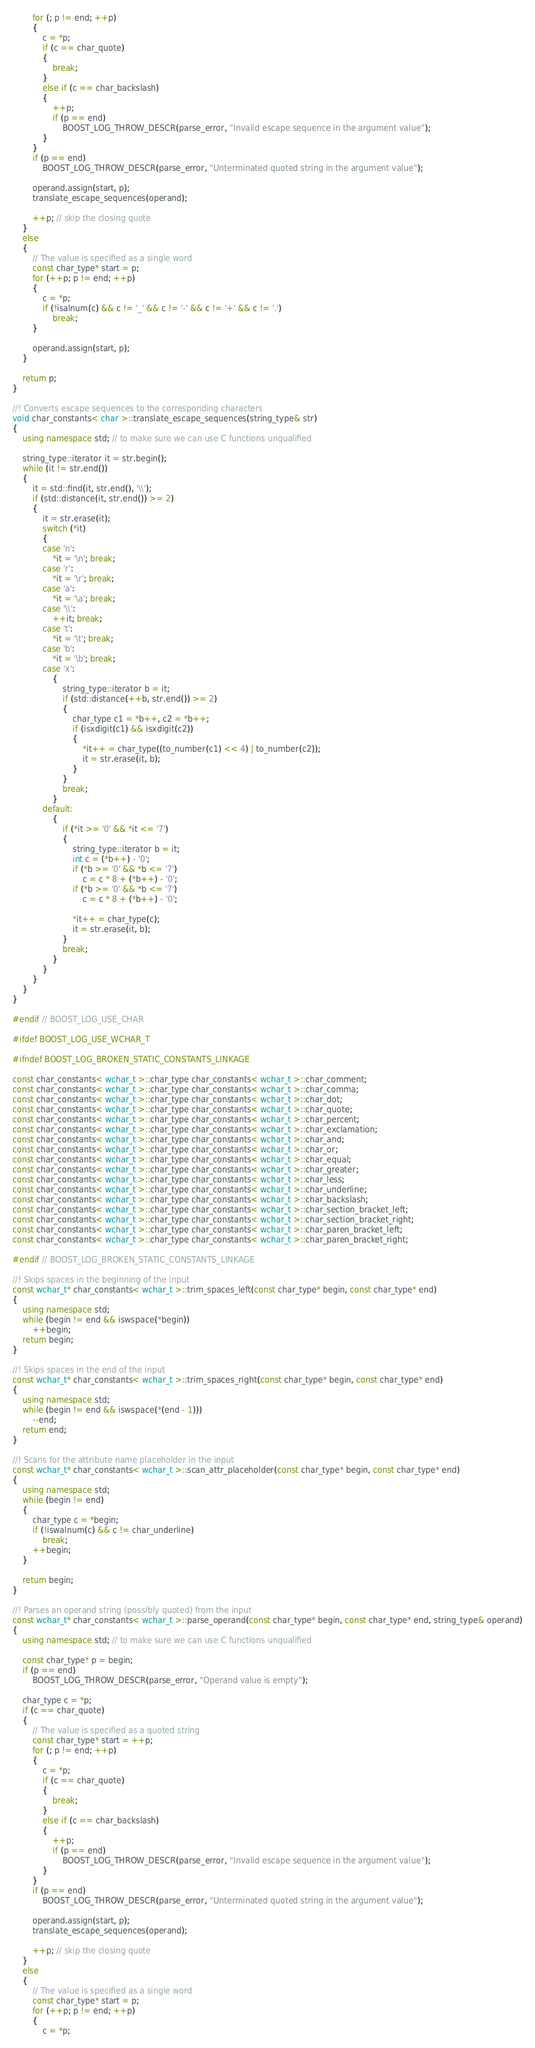Convert code to text. <code><loc_0><loc_0><loc_500><loc_500><_C++_>        for (; p != end; ++p)
        {
            c = *p;
            if (c == char_quote)
            {
                break;
            }
            else if (c == char_backslash)
            {
                ++p;
                if (p == end)
                    BOOST_LOG_THROW_DESCR(parse_error, "Invalid escape sequence in the argument value");
            }
        }
        if (p == end)
            BOOST_LOG_THROW_DESCR(parse_error, "Unterminated quoted string in the argument value");

        operand.assign(start, p);
        translate_escape_sequences(operand);

        ++p; // skip the closing quote
    }
    else
    {
        // The value is specified as a single word
        const char_type* start = p;
        for (++p; p != end; ++p)
        {
            c = *p;
            if (!isalnum(c) && c != '_' && c != '-' && c != '+' && c != '.')
                break;
        }

        operand.assign(start, p);
    }

    return p;
}

//! Converts escape sequences to the corresponding characters
void char_constants< char >::translate_escape_sequences(string_type& str)
{
    using namespace std; // to make sure we can use C functions unqualified

    string_type::iterator it = str.begin();
    while (it != str.end())
    {
        it = std::find(it, str.end(), '\\');
        if (std::distance(it, str.end()) >= 2)
        {
            it = str.erase(it);
            switch (*it)
            {
            case 'n':
                *it = '\n'; break;
            case 'r':
                *it = '\r'; break;
            case 'a':
                *it = '\a'; break;
            case '\\':
                ++it; break;
            case 't':
                *it = '\t'; break;
            case 'b':
                *it = '\b'; break;
            case 'x':
                {
                    string_type::iterator b = it;
                    if (std::distance(++b, str.end()) >= 2)
                    {
                        char_type c1 = *b++, c2 = *b++;
                        if (isxdigit(c1) && isxdigit(c2))
                        {
                            *it++ = char_type((to_number(c1) << 4) | to_number(c2));
                            it = str.erase(it, b);
                        }
                    }
                    break;
                }
            default:
                {
                    if (*it >= '0' && *it <= '7')
                    {
                        string_type::iterator b = it;
                        int c = (*b++) - '0';
                        if (*b >= '0' && *b <= '7')
                            c = c * 8 + (*b++) - '0';
                        if (*b >= '0' && *b <= '7')
                            c = c * 8 + (*b++) - '0';

                        *it++ = char_type(c);
                        it = str.erase(it, b);
                    }
                    break;
                }
            }
        }
    }
}

#endif // BOOST_LOG_USE_CHAR

#ifdef BOOST_LOG_USE_WCHAR_T

#ifndef BOOST_LOG_BROKEN_STATIC_CONSTANTS_LINKAGE

const char_constants< wchar_t >::char_type char_constants< wchar_t >::char_comment;
const char_constants< wchar_t >::char_type char_constants< wchar_t >::char_comma;
const char_constants< wchar_t >::char_type char_constants< wchar_t >::char_dot;
const char_constants< wchar_t >::char_type char_constants< wchar_t >::char_quote;
const char_constants< wchar_t >::char_type char_constants< wchar_t >::char_percent;
const char_constants< wchar_t >::char_type char_constants< wchar_t >::char_exclamation;
const char_constants< wchar_t >::char_type char_constants< wchar_t >::char_and;
const char_constants< wchar_t >::char_type char_constants< wchar_t >::char_or;
const char_constants< wchar_t >::char_type char_constants< wchar_t >::char_equal;
const char_constants< wchar_t >::char_type char_constants< wchar_t >::char_greater;
const char_constants< wchar_t >::char_type char_constants< wchar_t >::char_less;
const char_constants< wchar_t >::char_type char_constants< wchar_t >::char_underline;
const char_constants< wchar_t >::char_type char_constants< wchar_t >::char_backslash;
const char_constants< wchar_t >::char_type char_constants< wchar_t >::char_section_bracket_left;
const char_constants< wchar_t >::char_type char_constants< wchar_t >::char_section_bracket_right;
const char_constants< wchar_t >::char_type char_constants< wchar_t >::char_paren_bracket_left;
const char_constants< wchar_t >::char_type char_constants< wchar_t >::char_paren_bracket_right;

#endif // BOOST_LOG_BROKEN_STATIC_CONSTANTS_LINKAGE

//! Skips spaces in the beginning of the input
const wchar_t* char_constants< wchar_t >::trim_spaces_left(const char_type* begin, const char_type* end)
{
    using namespace std;
    while (begin != end && iswspace(*begin))
        ++begin;
    return begin;
}

//! Skips spaces in the end of the input
const wchar_t* char_constants< wchar_t >::trim_spaces_right(const char_type* begin, const char_type* end)
{
    using namespace std;
    while (begin != end && iswspace(*(end - 1)))
        --end;
    return end;
}

//! Scans for the attribute name placeholder in the input
const wchar_t* char_constants< wchar_t >::scan_attr_placeholder(const char_type* begin, const char_type* end)
{
    using namespace std;
    while (begin != end)
    {
        char_type c = *begin;
        if (!iswalnum(c) && c != char_underline)
            break;
        ++begin;
    }

    return begin;
}

//! Parses an operand string (possibly quoted) from the input
const wchar_t* char_constants< wchar_t >::parse_operand(const char_type* begin, const char_type* end, string_type& operand)
{
    using namespace std; // to make sure we can use C functions unqualified

    const char_type* p = begin;
    if (p == end)
        BOOST_LOG_THROW_DESCR(parse_error, "Operand value is empty");

    char_type c = *p;
    if (c == char_quote)
    {
        // The value is specified as a quoted string
        const char_type* start = ++p;
        for (; p != end; ++p)
        {
            c = *p;
            if (c == char_quote)
            {
                break;
            }
            else if (c == char_backslash)
            {
                ++p;
                if (p == end)
                    BOOST_LOG_THROW_DESCR(parse_error, "Invalid escape sequence in the argument value");
            }
        }
        if (p == end)
            BOOST_LOG_THROW_DESCR(parse_error, "Unterminated quoted string in the argument value");

        operand.assign(start, p);
        translate_escape_sequences(operand);

        ++p; // skip the closing quote
    }
    else
    {
        // The value is specified as a single word
        const char_type* start = p;
        for (++p; p != end; ++p)
        {
            c = *p;</code> 